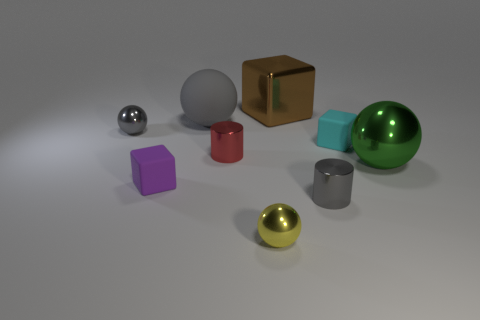Subtract all small cubes. How many cubes are left? 1 Add 1 tiny cylinders. How many objects exist? 10 Subtract all gray balls. How many balls are left? 2 Subtract 3 cubes. How many cubes are left? 0 Subtract all spheres. How many objects are left? 5 Subtract all gray cylinders. How many brown blocks are left? 1 Add 1 rubber cubes. How many rubber cubes are left? 3 Add 4 gray things. How many gray things exist? 7 Subtract 0 yellow cylinders. How many objects are left? 9 Subtract all yellow balls. Subtract all purple cubes. How many balls are left? 3 